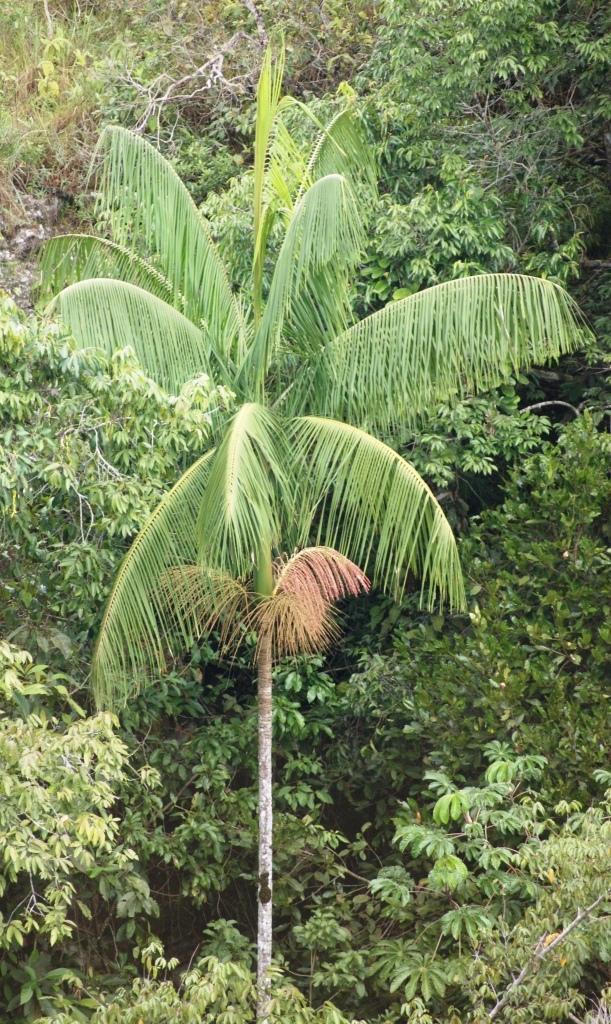In one or two sentences, can you explain what this image depicts? In this image in the foreground there is the biggest tree and it is surrounded by many other trees. 